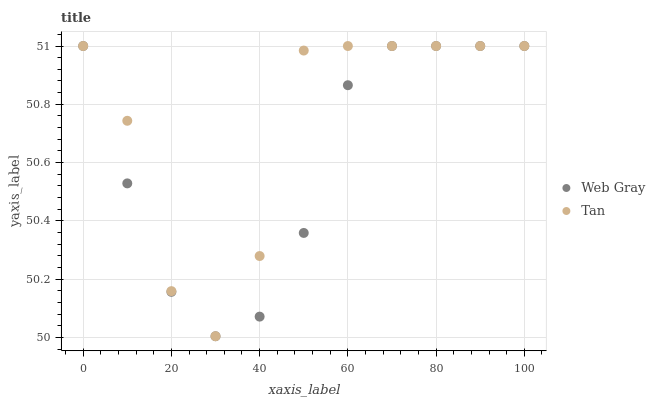Does Web Gray have the minimum area under the curve?
Answer yes or no. Yes. Does Tan have the maximum area under the curve?
Answer yes or no. Yes. Does Web Gray have the maximum area under the curve?
Answer yes or no. No. Is Web Gray the smoothest?
Answer yes or no. Yes. Is Tan the roughest?
Answer yes or no. Yes. Is Web Gray the roughest?
Answer yes or no. No. Does Web Gray have the lowest value?
Answer yes or no. Yes. Does Web Gray have the highest value?
Answer yes or no. Yes. Does Web Gray intersect Tan?
Answer yes or no. Yes. Is Web Gray less than Tan?
Answer yes or no. No. Is Web Gray greater than Tan?
Answer yes or no. No. 